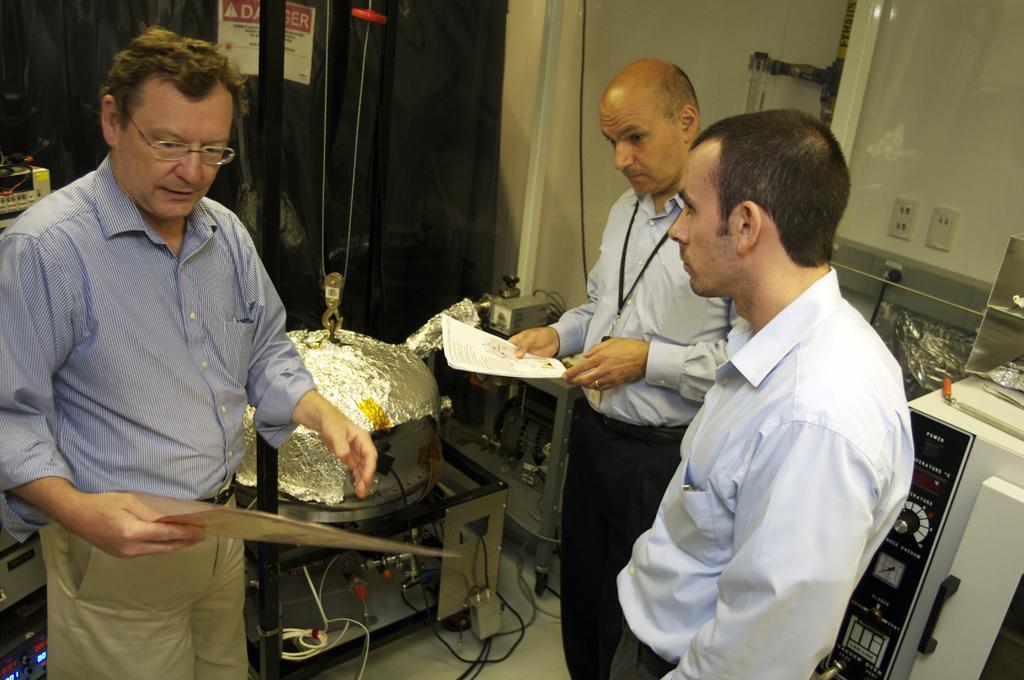Could you give a brief overview of what you see in this image? On the left side, there is a person, wearing a spectacle and holding a document. On the right side, there are two persons with blue color shirts, standing. One of them is holding a document. Behind them, there is a machine. In the background, there is a wall, a cupboard, a cable and other objects. 